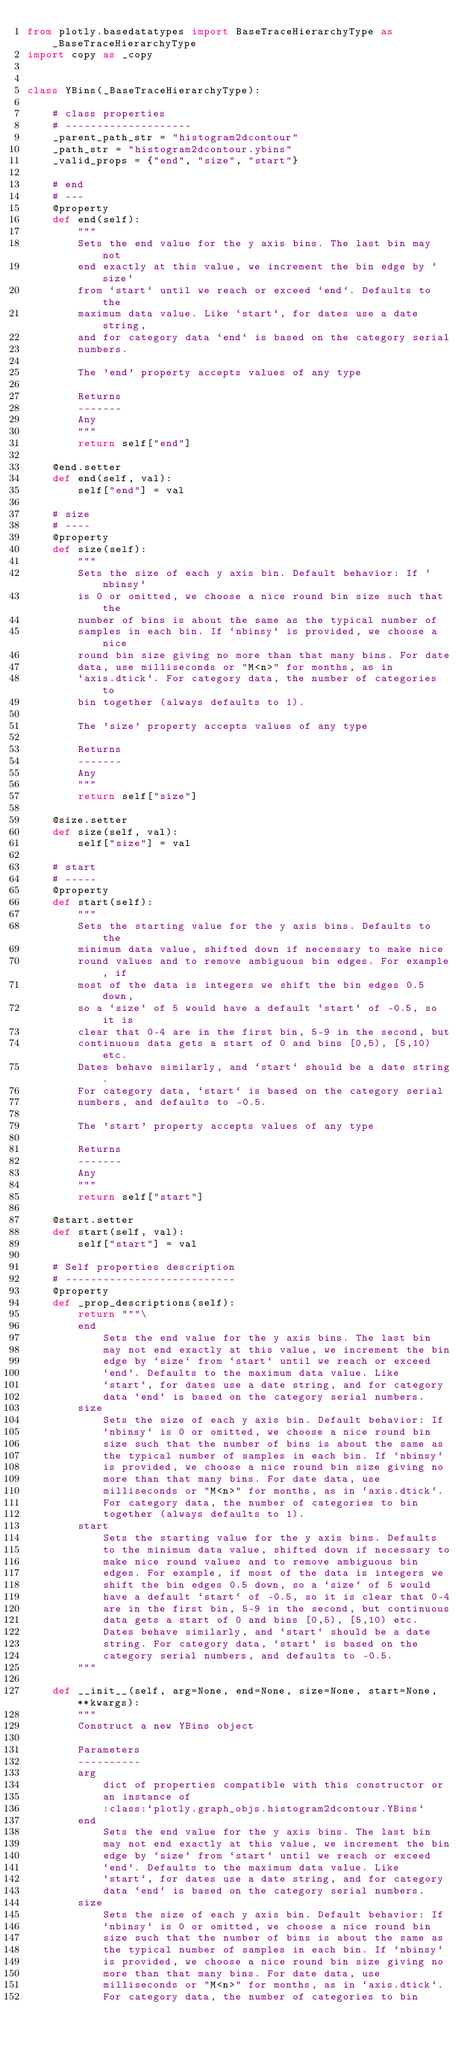<code> <loc_0><loc_0><loc_500><loc_500><_Python_>from plotly.basedatatypes import BaseTraceHierarchyType as _BaseTraceHierarchyType
import copy as _copy


class YBins(_BaseTraceHierarchyType):

    # class properties
    # --------------------
    _parent_path_str = "histogram2dcontour"
    _path_str = "histogram2dcontour.ybins"
    _valid_props = {"end", "size", "start"}

    # end
    # ---
    @property
    def end(self):
        """
        Sets the end value for the y axis bins. The last bin may not
        end exactly at this value, we increment the bin edge by `size`
        from `start` until we reach or exceed `end`. Defaults to the
        maximum data value. Like `start`, for dates use a date string,
        and for category data `end` is based on the category serial
        numbers.
    
        The 'end' property accepts values of any type

        Returns
        -------
        Any
        """
        return self["end"]

    @end.setter
    def end(self, val):
        self["end"] = val

    # size
    # ----
    @property
    def size(self):
        """
        Sets the size of each y axis bin. Default behavior: If `nbinsy`
        is 0 or omitted, we choose a nice round bin size such that the
        number of bins is about the same as the typical number of
        samples in each bin. If `nbinsy` is provided, we choose a nice
        round bin size giving no more than that many bins. For date
        data, use milliseconds or "M<n>" for months, as in
        `axis.dtick`. For category data, the number of categories to
        bin together (always defaults to 1).
    
        The 'size' property accepts values of any type

        Returns
        -------
        Any
        """
        return self["size"]

    @size.setter
    def size(self, val):
        self["size"] = val

    # start
    # -----
    @property
    def start(self):
        """
        Sets the starting value for the y axis bins. Defaults to the
        minimum data value, shifted down if necessary to make nice
        round values and to remove ambiguous bin edges. For example, if
        most of the data is integers we shift the bin edges 0.5 down,
        so a `size` of 5 would have a default `start` of -0.5, so it is
        clear that 0-4 are in the first bin, 5-9 in the second, but
        continuous data gets a start of 0 and bins [0,5), [5,10) etc.
        Dates behave similarly, and `start` should be a date string.
        For category data, `start` is based on the category serial
        numbers, and defaults to -0.5.
    
        The 'start' property accepts values of any type

        Returns
        -------
        Any
        """
        return self["start"]

    @start.setter
    def start(self, val):
        self["start"] = val

    # Self properties description
    # ---------------------------
    @property
    def _prop_descriptions(self):
        return """\
        end
            Sets the end value for the y axis bins. The last bin
            may not end exactly at this value, we increment the bin
            edge by `size` from `start` until we reach or exceed
            `end`. Defaults to the maximum data value. Like
            `start`, for dates use a date string, and for category
            data `end` is based on the category serial numbers.
        size
            Sets the size of each y axis bin. Default behavior: If
            `nbinsy` is 0 or omitted, we choose a nice round bin
            size such that the number of bins is about the same as
            the typical number of samples in each bin. If `nbinsy`
            is provided, we choose a nice round bin size giving no
            more than that many bins. For date data, use
            milliseconds or "M<n>" for months, as in `axis.dtick`.
            For category data, the number of categories to bin
            together (always defaults to 1).
        start
            Sets the starting value for the y axis bins. Defaults
            to the minimum data value, shifted down if necessary to
            make nice round values and to remove ambiguous bin
            edges. For example, if most of the data is integers we
            shift the bin edges 0.5 down, so a `size` of 5 would
            have a default `start` of -0.5, so it is clear that 0-4
            are in the first bin, 5-9 in the second, but continuous
            data gets a start of 0 and bins [0,5), [5,10) etc.
            Dates behave similarly, and `start` should be a date
            string. For category data, `start` is based on the
            category serial numbers, and defaults to -0.5.
        """

    def __init__(self, arg=None, end=None, size=None, start=None, **kwargs):
        """
        Construct a new YBins object
        
        Parameters
        ----------
        arg
            dict of properties compatible with this constructor or
            an instance of
            :class:`plotly.graph_objs.histogram2dcontour.YBins`
        end
            Sets the end value for the y axis bins. The last bin
            may not end exactly at this value, we increment the bin
            edge by `size` from `start` until we reach or exceed
            `end`. Defaults to the maximum data value. Like
            `start`, for dates use a date string, and for category
            data `end` is based on the category serial numbers.
        size
            Sets the size of each y axis bin. Default behavior: If
            `nbinsy` is 0 or omitted, we choose a nice round bin
            size such that the number of bins is about the same as
            the typical number of samples in each bin. If `nbinsy`
            is provided, we choose a nice round bin size giving no
            more than that many bins. For date data, use
            milliseconds or "M<n>" for months, as in `axis.dtick`.
            For category data, the number of categories to bin</code> 